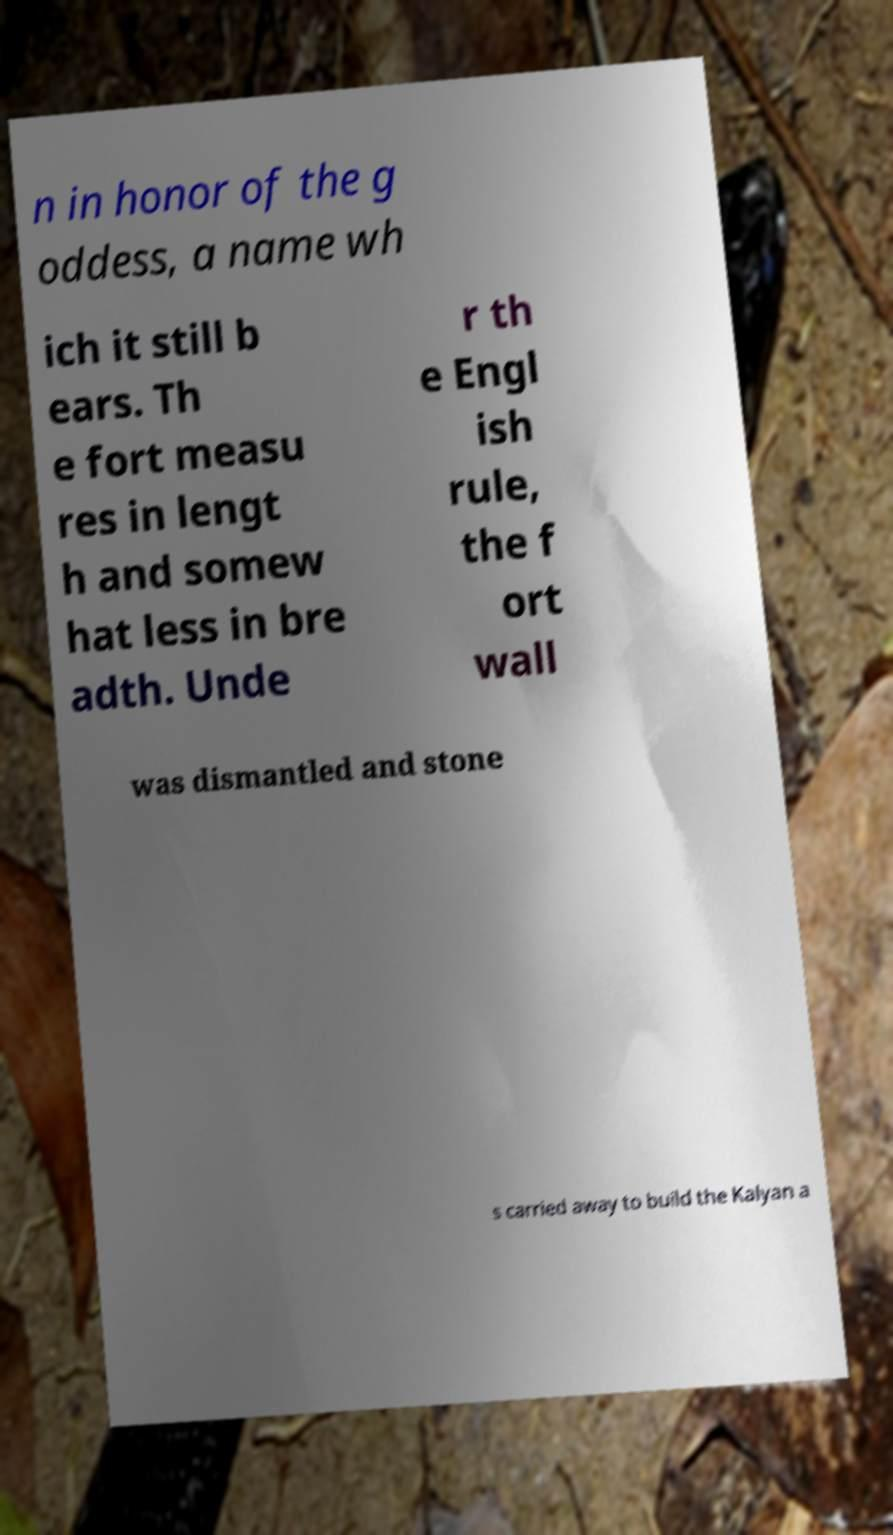What messages or text are displayed in this image? I need them in a readable, typed format. n in honor of the g oddess, a name wh ich it still b ears. Th e fort measu res in lengt h and somew hat less in bre adth. Unde r th e Engl ish rule, the f ort wall was dismantled and stone s carried away to build the Kalyan a 